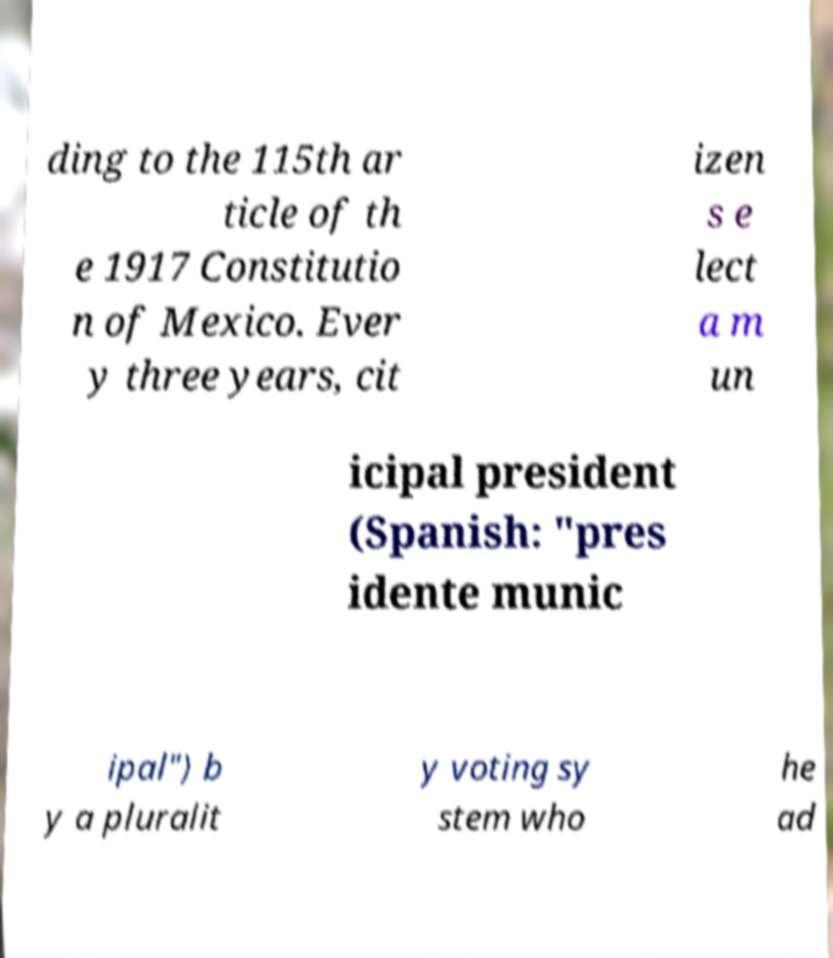Can you read and provide the text displayed in the image?This photo seems to have some interesting text. Can you extract and type it out for me? ding to the 115th ar ticle of th e 1917 Constitutio n of Mexico. Ever y three years, cit izen s e lect a m un icipal president (Spanish: "pres idente munic ipal") b y a pluralit y voting sy stem who he ad 